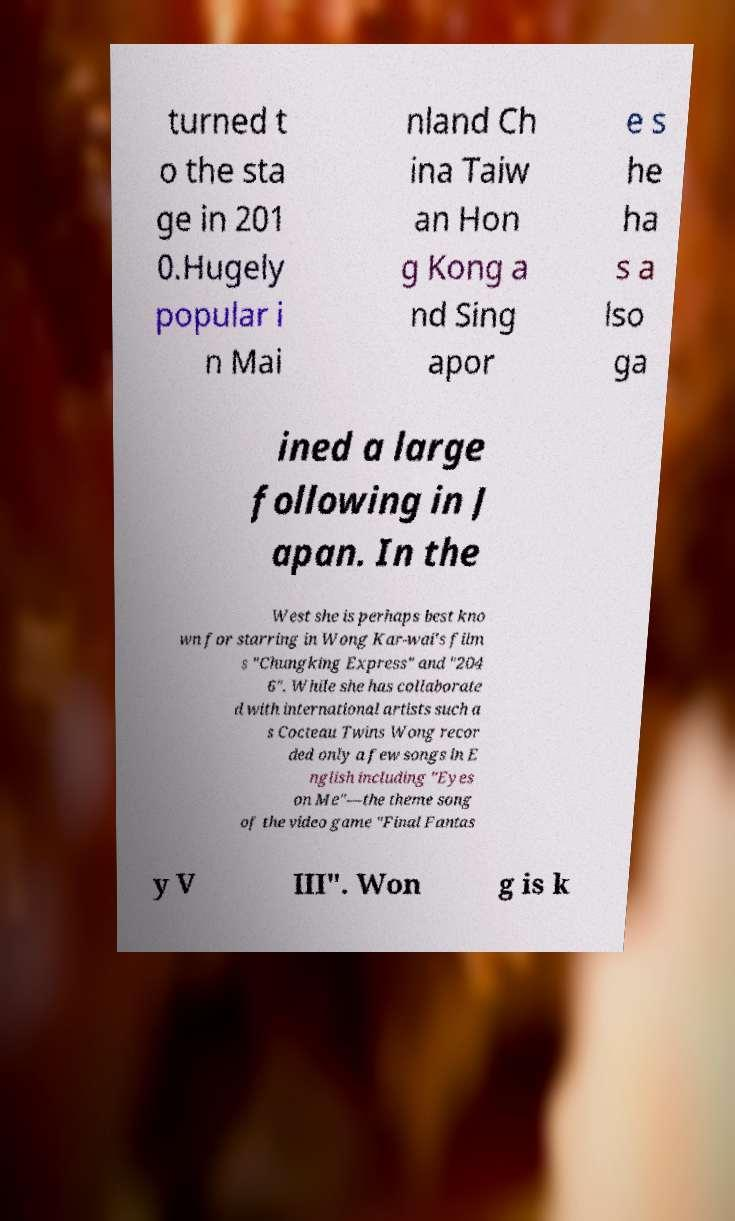There's text embedded in this image that I need extracted. Can you transcribe it verbatim? turned t o the sta ge in 201 0.Hugely popular i n Mai nland Ch ina Taiw an Hon g Kong a nd Sing apor e s he ha s a lso ga ined a large following in J apan. In the West she is perhaps best kno wn for starring in Wong Kar-wai's film s "Chungking Express" and "204 6". While she has collaborate d with international artists such a s Cocteau Twins Wong recor ded only a few songs in E nglish including "Eyes on Me"—the theme song of the video game "Final Fantas y V III". Won g is k 